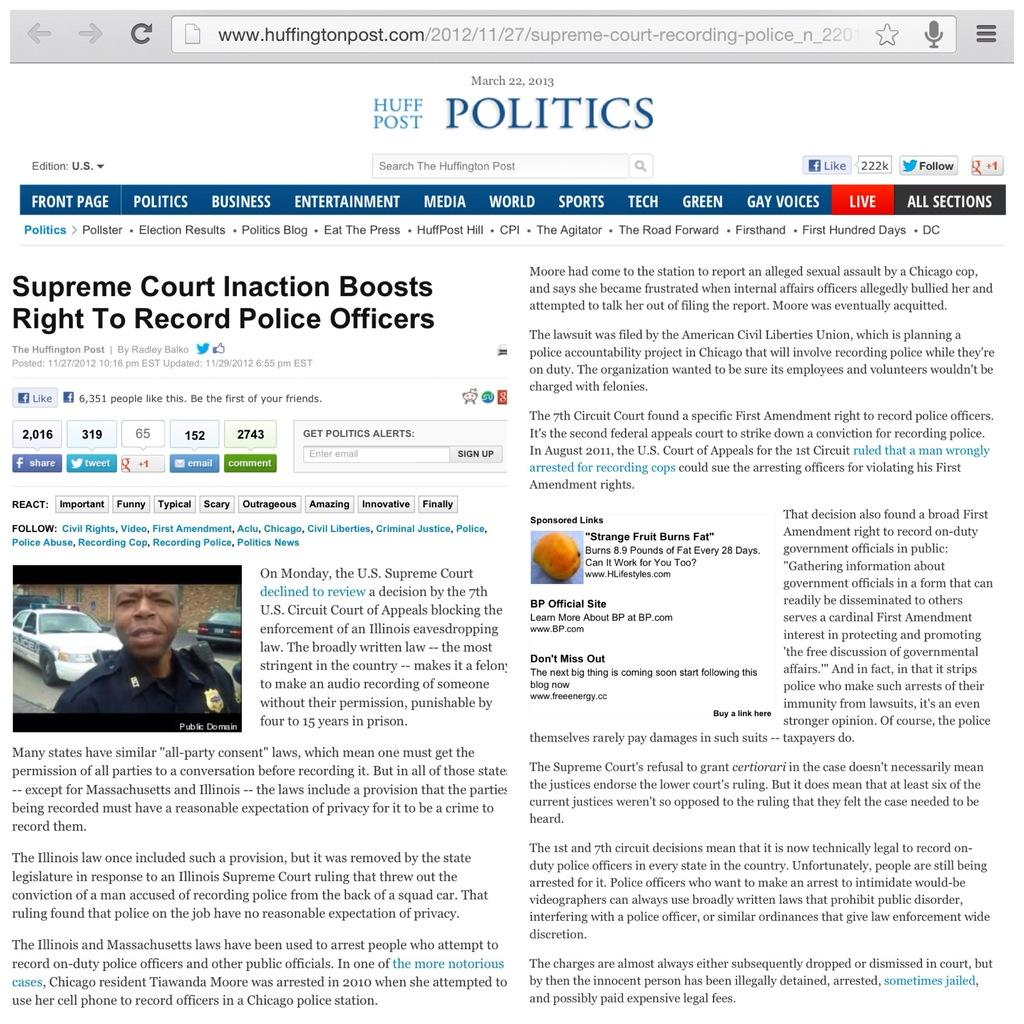What is the main subject of the image? The main subject of the image is a web page. What can be found on the web page? There is text on the web page. Where is the person located in the image? The person is on the left side of the image. What else is on the left side of the image? There is a car on the left side of the image. What is the color of the background in the image? The background of the image is white. What type of furniture can be seen in the image? There is no furniture present in the image. How many mittens are visible in the image? There are no mittens present in the image. 